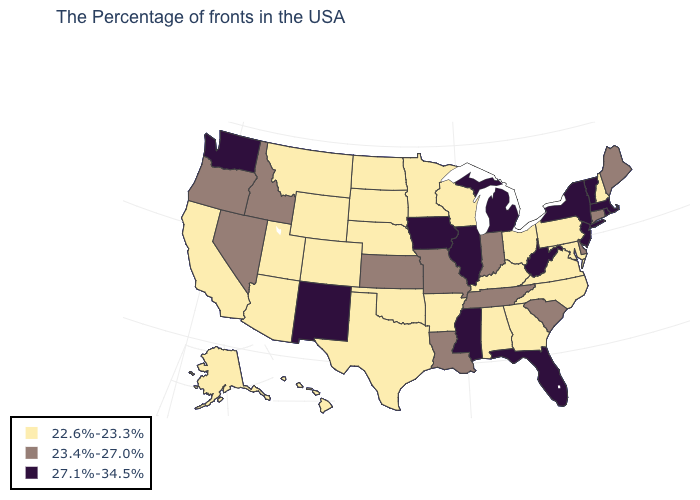Among the states that border Nebraska , does South Dakota have the lowest value?
Concise answer only. Yes. What is the value of Delaware?
Be succinct. 23.4%-27.0%. Which states have the lowest value in the USA?
Keep it brief. New Hampshire, Maryland, Pennsylvania, Virginia, North Carolina, Ohio, Georgia, Kentucky, Alabama, Wisconsin, Arkansas, Minnesota, Nebraska, Oklahoma, Texas, South Dakota, North Dakota, Wyoming, Colorado, Utah, Montana, Arizona, California, Alaska, Hawaii. Does West Virginia have the lowest value in the USA?
Quick response, please. No. Among the states that border Arkansas , which have the lowest value?
Give a very brief answer. Oklahoma, Texas. Does Pennsylvania have the highest value in the Northeast?
Concise answer only. No. What is the value of Minnesota?
Be succinct. 22.6%-23.3%. Among the states that border Missouri , does Illinois have the highest value?
Give a very brief answer. Yes. Among the states that border New Mexico , which have the highest value?
Give a very brief answer. Oklahoma, Texas, Colorado, Utah, Arizona. Name the states that have a value in the range 22.6%-23.3%?
Answer briefly. New Hampshire, Maryland, Pennsylvania, Virginia, North Carolina, Ohio, Georgia, Kentucky, Alabama, Wisconsin, Arkansas, Minnesota, Nebraska, Oklahoma, Texas, South Dakota, North Dakota, Wyoming, Colorado, Utah, Montana, Arizona, California, Alaska, Hawaii. How many symbols are there in the legend?
Give a very brief answer. 3. Does the first symbol in the legend represent the smallest category?
Keep it brief. Yes. Among the states that border Mississippi , which have the lowest value?
Short answer required. Alabama, Arkansas. What is the highest value in the West ?
Be succinct. 27.1%-34.5%. 